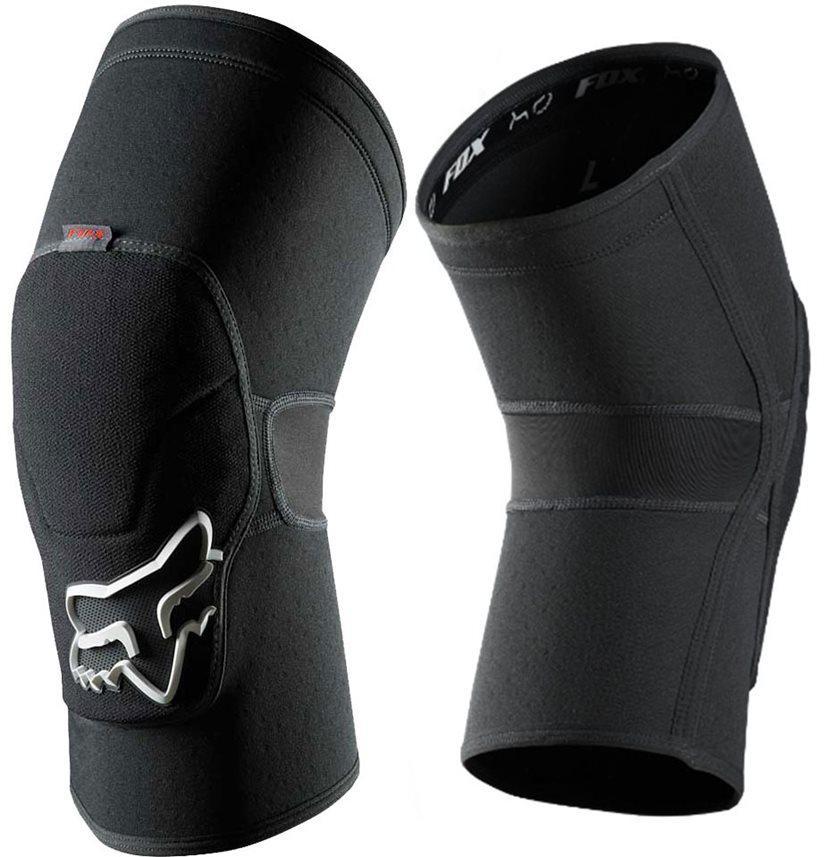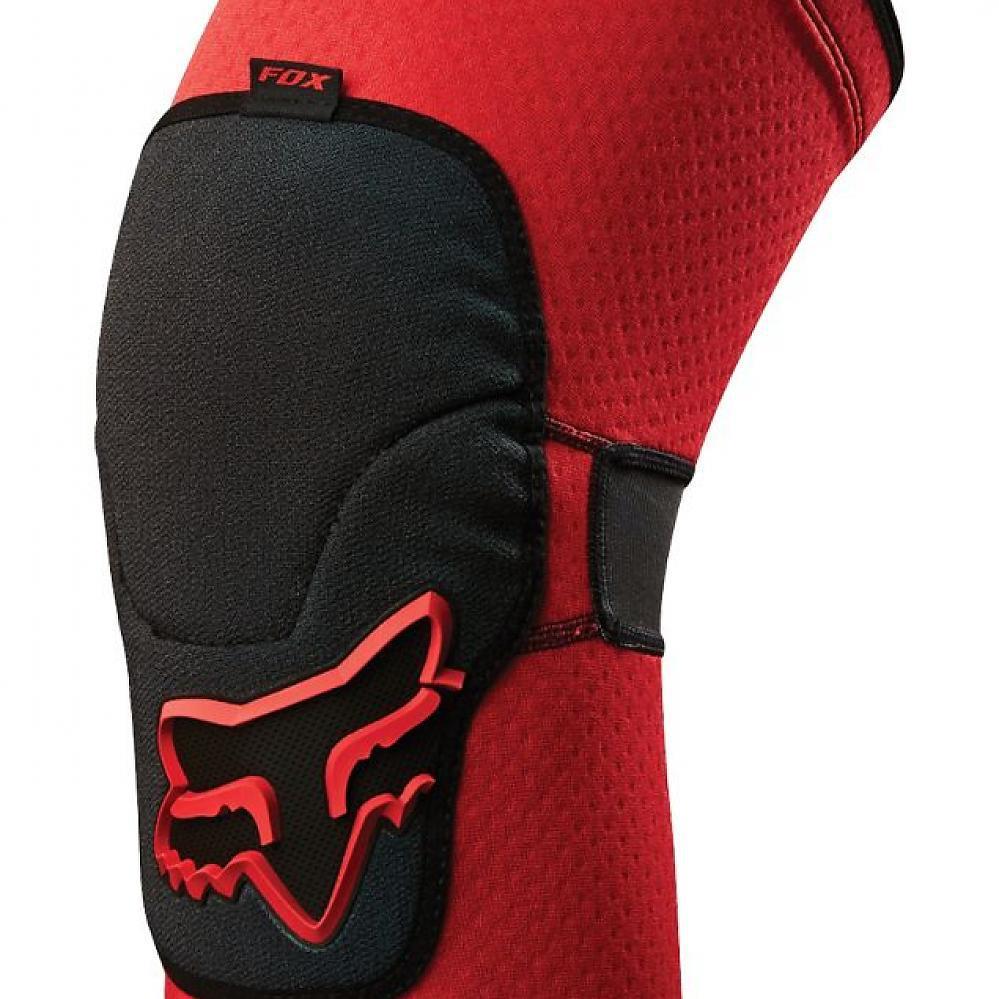The first image is the image on the left, the second image is the image on the right. For the images shown, is this caption "There are no less than two knee pads that are red and black in color" true? Answer yes or no. No. 